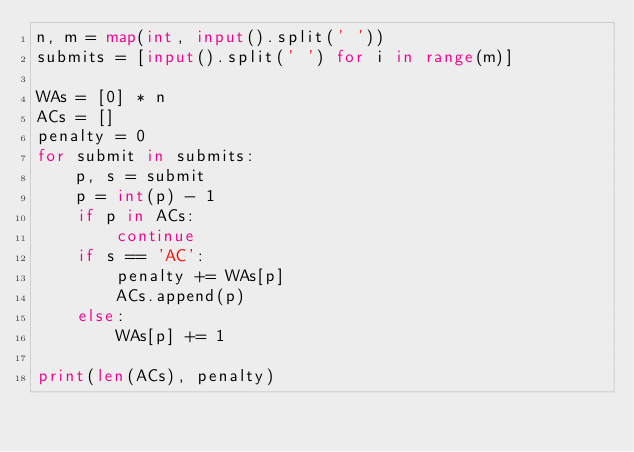<code> <loc_0><loc_0><loc_500><loc_500><_Python_>n, m = map(int, input().split(' '))
submits = [input().split(' ') for i in range(m)]

WAs = [0] * n
ACs = []
penalty = 0
for submit in submits:
    p, s = submit
    p = int(p) - 1
    if p in ACs:
        continue
    if s == 'AC':
        penalty += WAs[p]
        ACs.append(p)
    else:
        WAs[p] += 1

print(len(ACs), penalty)
</code> 